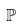<formula> <loc_0><loc_0><loc_500><loc_500>\mathbb { P }</formula> 